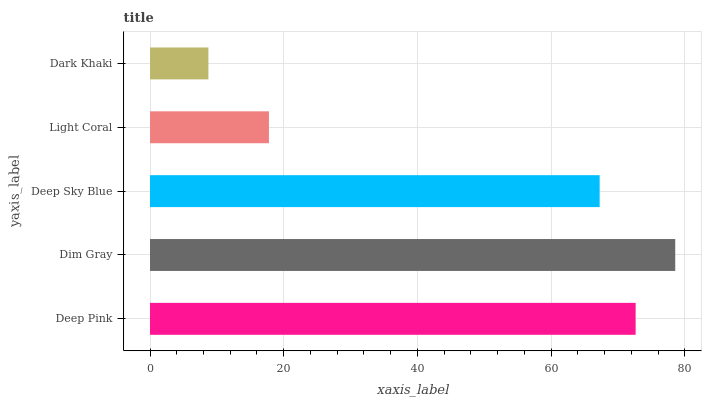Is Dark Khaki the minimum?
Answer yes or no. Yes. Is Dim Gray the maximum?
Answer yes or no. Yes. Is Deep Sky Blue the minimum?
Answer yes or no. No. Is Deep Sky Blue the maximum?
Answer yes or no. No. Is Dim Gray greater than Deep Sky Blue?
Answer yes or no. Yes. Is Deep Sky Blue less than Dim Gray?
Answer yes or no. Yes. Is Deep Sky Blue greater than Dim Gray?
Answer yes or no. No. Is Dim Gray less than Deep Sky Blue?
Answer yes or no. No. Is Deep Sky Blue the high median?
Answer yes or no. Yes. Is Deep Sky Blue the low median?
Answer yes or no. Yes. Is Dim Gray the high median?
Answer yes or no. No. Is Deep Pink the low median?
Answer yes or no. No. 